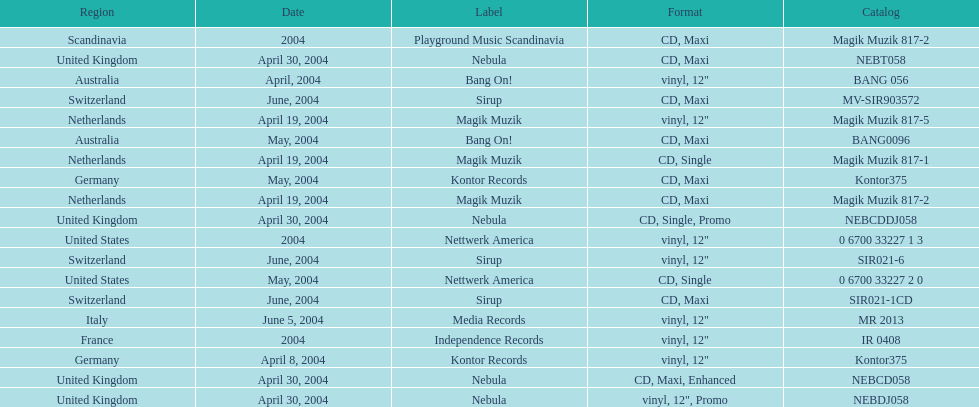What format did france use? Vinyl, 12". Would you mind parsing the complete table? {'header': ['Region', 'Date', 'Label', 'Format', 'Catalog'], 'rows': [['Scandinavia', '2004', 'Playground Music Scandinavia', 'CD, Maxi', 'Magik Muzik 817-2'], ['United Kingdom', 'April 30, 2004', 'Nebula', 'CD, Maxi', 'NEBT058'], ['Australia', 'April, 2004', 'Bang On!', 'vinyl, 12"', 'BANG 056'], ['Switzerland', 'June, 2004', 'Sirup', 'CD, Maxi', 'MV-SIR903572'], ['Netherlands', 'April 19, 2004', 'Magik Muzik', 'vinyl, 12"', 'Magik Muzik 817-5'], ['Australia', 'May, 2004', 'Bang On!', 'CD, Maxi', 'BANG0096'], ['Netherlands', 'April 19, 2004', 'Magik Muzik', 'CD, Single', 'Magik Muzik 817-1'], ['Germany', 'May, 2004', 'Kontor Records', 'CD, Maxi', 'Kontor375'], ['Netherlands', 'April 19, 2004', 'Magik Muzik', 'CD, Maxi', 'Magik Muzik 817-2'], ['United Kingdom', 'April 30, 2004', 'Nebula', 'CD, Single, Promo', 'NEBCDDJ058'], ['United States', '2004', 'Nettwerk America', 'vinyl, 12"', '0 6700 33227 1 3'], ['Switzerland', 'June, 2004', 'Sirup', 'vinyl, 12"', 'SIR021-6'], ['United States', 'May, 2004', 'Nettwerk America', 'CD, Single', '0 6700 33227 2 0'], ['Switzerland', 'June, 2004', 'Sirup', 'CD, Maxi', 'SIR021-1CD'], ['Italy', 'June 5, 2004', 'Media Records', 'vinyl, 12"', 'MR 2013'], ['France', '2004', 'Independence Records', 'vinyl, 12"', 'IR 0408'], ['Germany', 'April 8, 2004', 'Kontor Records', 'vinyl, 12"', 'Kontor375'], ['United Kingdom', 'April 30, 2004', 'Nebula', 'CD, Maxi, Enhanced', 'NEBCD058'], ['United Kingdom', 'April 30, 2004', 'Nebula', 'vinyl, 12", Promo', 'NEBDJ058']]} 